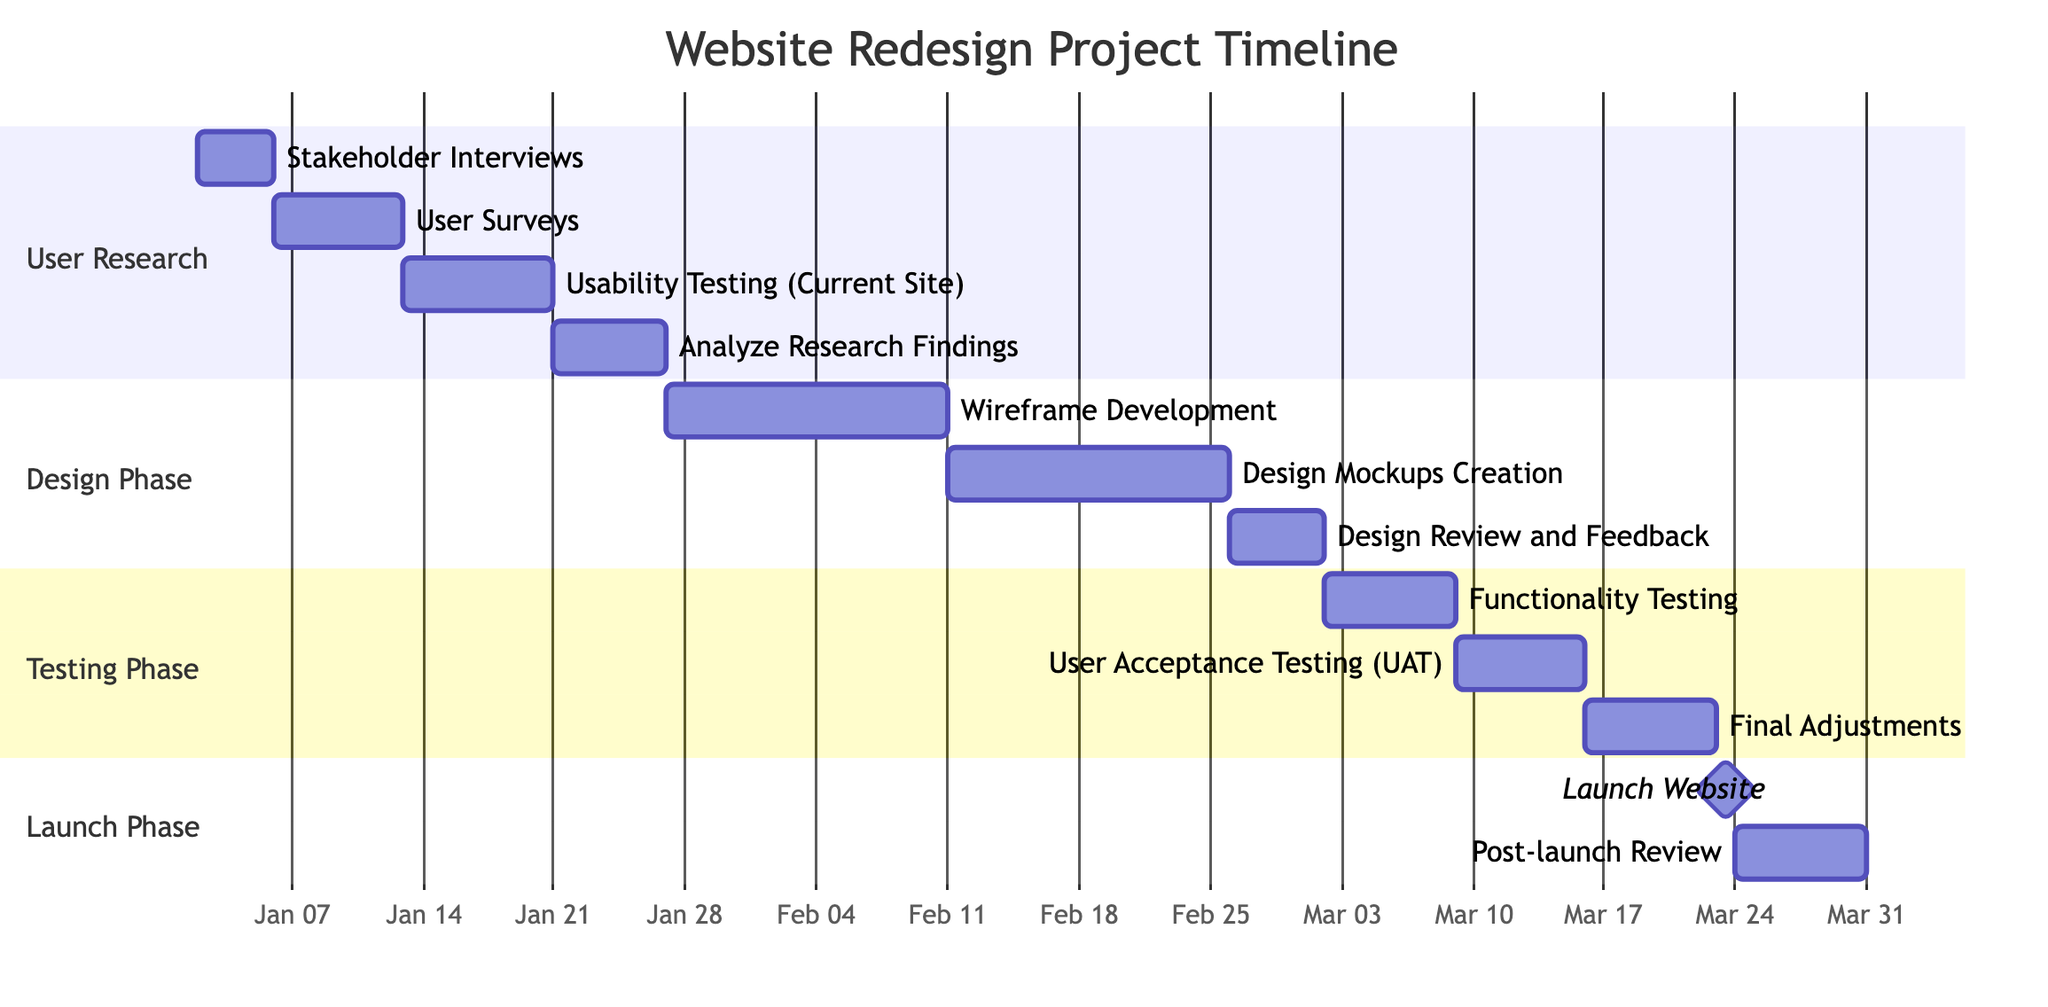What is the duration for the User Surveys task? The User Surveys task starts on January 6, 2024, and ends on January 12, 2024. The duration can be calculated as the difference between the end date and the start date, which is 7 days.
Answer: 7 days How many tasks are in the Design Phase? In the Design Phase, there are three tasks listed: Wireframe Development, Design Mockups Creation, and Design Review and Feedback. Thus, the total number of tasks is three.
Answer: 3 tasks What is the start date of the Usability Testing task? The Usability Testing task begins on January 13, 2024, according to the diagram information.
Answer: January 13, 2024 Which phase does the Analyze Research Findings task belong to? The Analyze Research Findings task is listed under the User Research phase, as it is one of the milestones aligned with that phase.
Answer: User Research What is the last milestone of the entire project timeline? The last milestone denoted in the Gantt chart is the Post-launch Review, which starts on March 24, 2024, following the Launch Website milestone.
Answer: Post-launch Review How many days does the Functionality Testing task take? The Functionality Testing task spans from March 2, 2024, to March 8, 2024. Hence, this task takes 7 days as indicated by the dates.
Answer: 7 days Which task overlaps with the Design Review and Feedback task? The Design Review and Feedback task runs from February 26, 2024, to March 1, 2024. The Functionality Testing task starts on March 2, making it the next task after the review. There are no overlapping tasks. Thus, the answer is that there are no overlaps.
Answer: None What is the duration of the launch phase? The launch phase consists of two tasks: Launch Website (1 day) and Post-launch Review (7 days). The total duration will be the sum of these durations, which is 8 days for the entire phase.
Answer: 8 days 